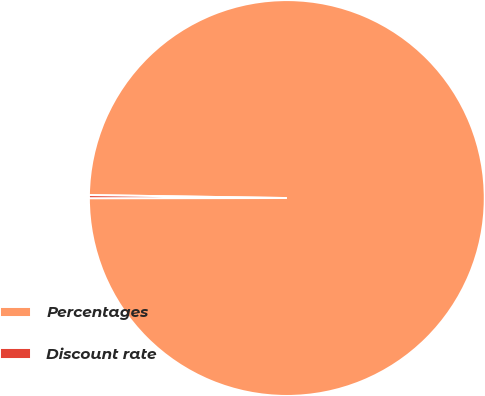<chart> <loc_0><loc_0><loc_500><loc_500><pie_chart><fcel>Percentages<fcel>Discount rate<nl><fcel>99.75%<fcel>0.25%<nl></chart> 